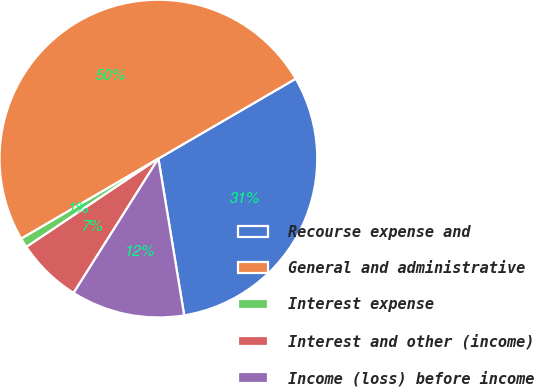Convert chart to OTSL. <chart><loc_0><loc_0><loc_500><loc_500><pie_chart><fcel>Recourse expense and<fcel>General and administrative<fcel>Interest expense<fcel>Interest and other (income)<fcel>Income (loss) before income<nl><fcel>30.79%<fcel>50.03%<fcel>0.98%<fcel>6.65%<fcel>11.56%<nl></chart> 